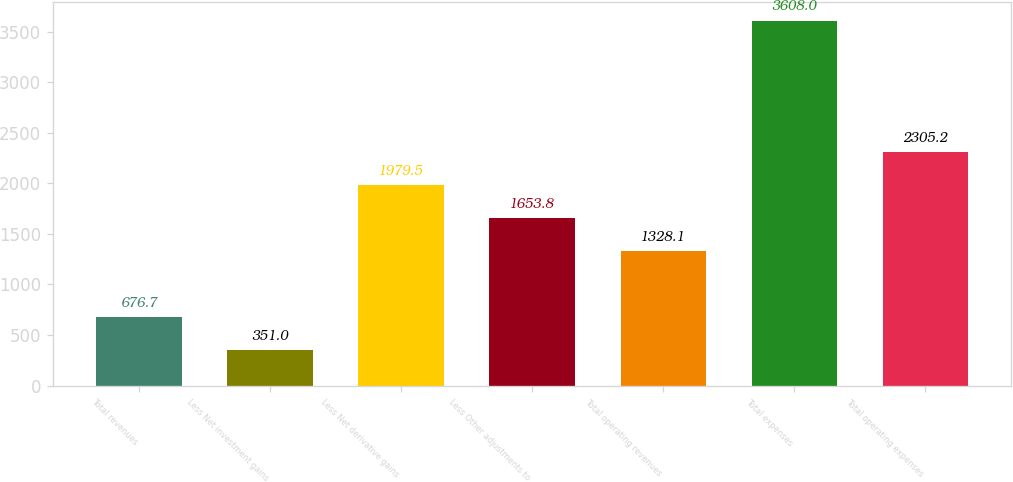<chart> <loc_0><loc_0><loc_500><loc_500><bar_chart><fcel>Total revenues<fcel>Less Net investment gains<fcel>Less Net derivative gains<fcel>Less Other adjustments to<fcel>Total operating revenues<fcel>Total expenses<fcel>Total operating expenses<nl><fcel>676.7<fcel>351<fcel>1979.5<fcel>1653.8<fcel>1328.1<fcel>3608<fcel>2305.2<nl></chart> 